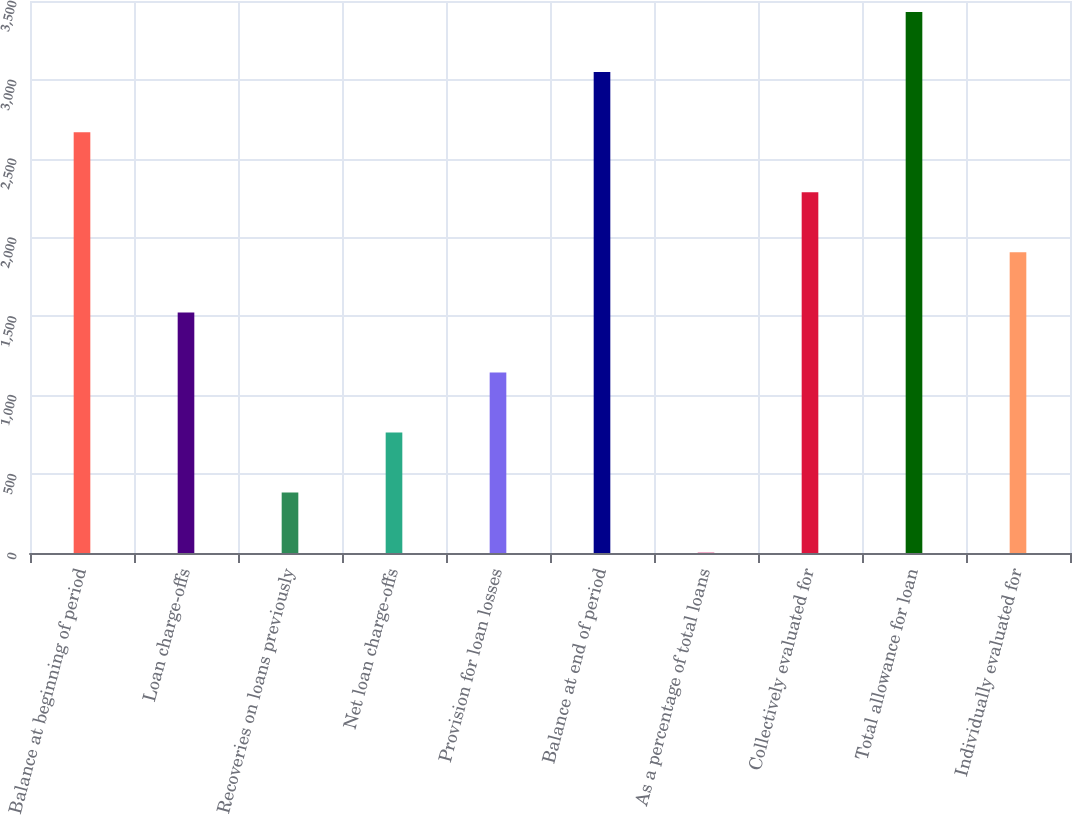<chart> <loc_0><loc_0><loc_500><loc_500><bar_chart><fcel>Balance at beginning of period<fcel>Loan charge-offs<fcel>Recoveries on loans previously<fcel>Net loan charge-offs<fcel>Provision for loan losses<fcel>Balance at end of period<fcel>As a percentage of total loans<fcel>Collectively evaluated for<fcel>Total allowance for loan<fcel>Individually evaluated for<nl><fcel>2668.34<fcel>1525.64<fcel>382.94<fcel>763.84<fcel>1144.74<fcel>3049.24<fcel>2.04<fcel>2287.44<fcel>3430.14<fcel>1906.54<nl></chart> 